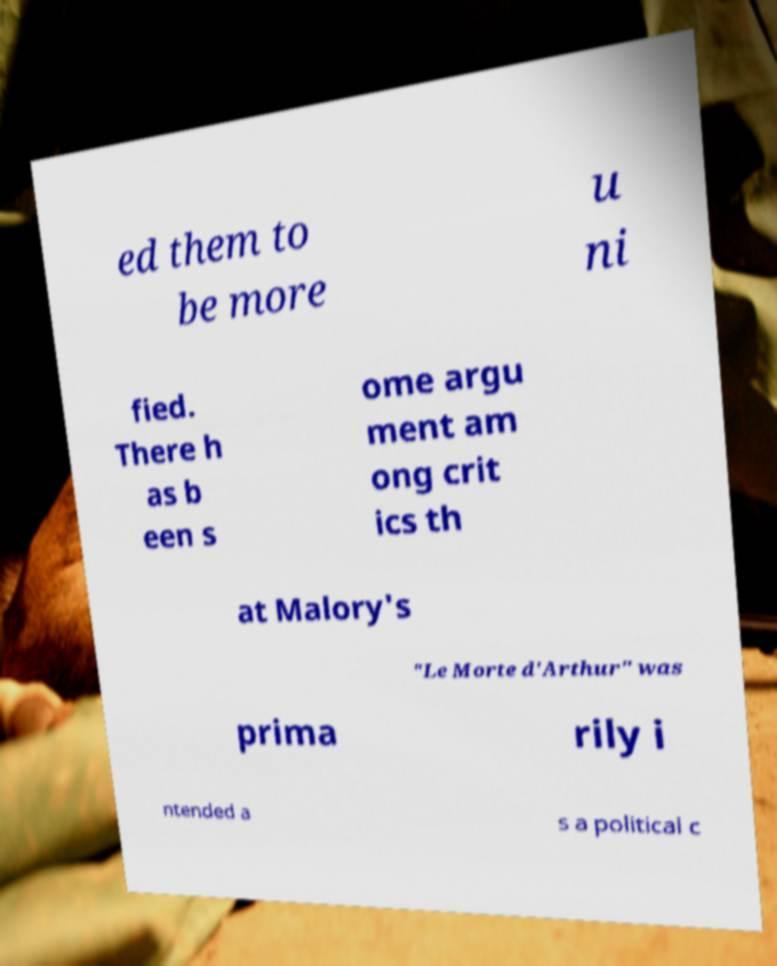Could you assist in decoding the text presented in this image and type it out clearly? ed them to be more u ni fied. There h as b een s ome argu ment am ong crit ics th at Malory's "Le Morte d'Arthur" was prima rily i ntended a s a political c 